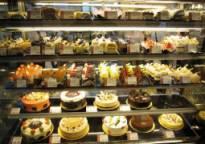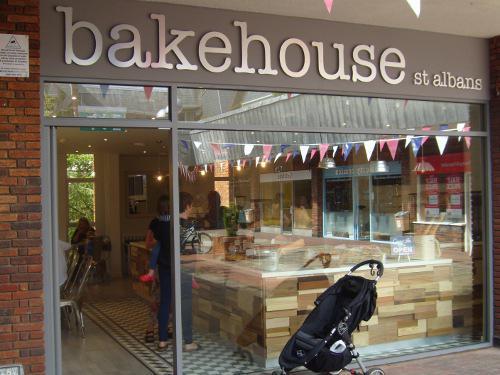The first image is the image on the left, the second image is the image on the right. Examine the images to the left and right. Is the description "Traingular pennants are on display in the image on the right." accurate? Answer yes or no. Yes. 